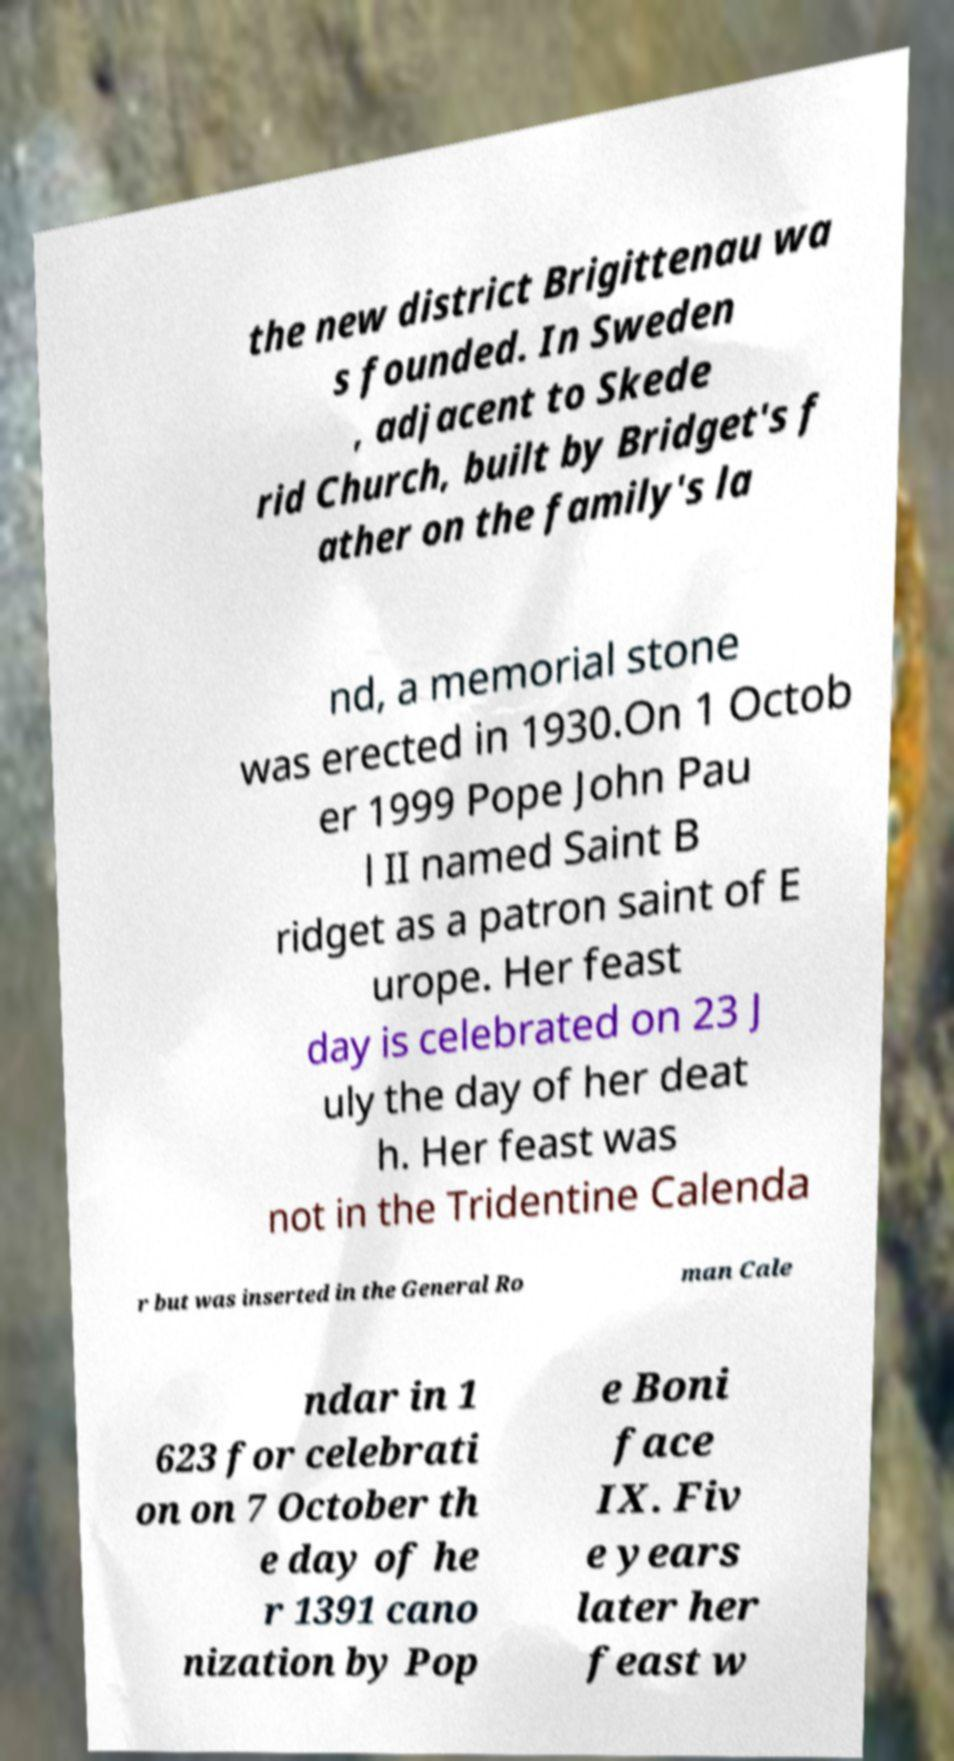For documentation purposes, I need the text within this image transcribed. Could you provide that? the new district Brigittenau wa s founded. In Sweden , adjacent to Skede rid Church, built by Bridget's f ather on the family's la nd, a memorial stone was erected in 1930.On 1 Octob er 1999 Pope John Pau l II named Saint B ridget as a patron saint of E urope. Her feast day is celebrated on 23 J uly the day of her deat h. Her feast was not in the Tridentine Calenda r but was inserted in the General Ro man Cale ndar in 1 623 for celebrati on on 7 October th e day of he r 1391 cano nization by Pop e Boni face IX. Fiv e years later her feast w 